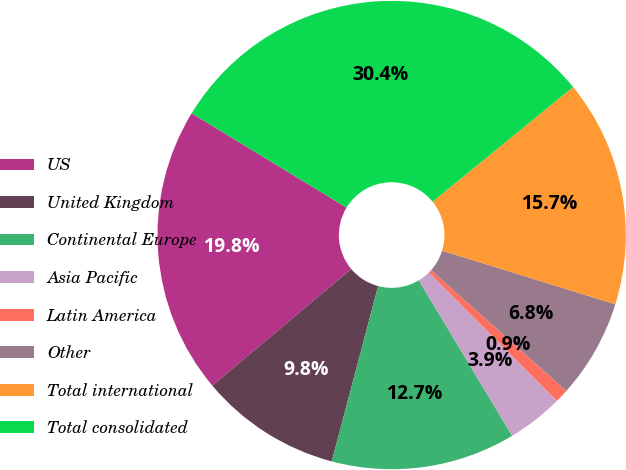Convert chart. <chart><loc_0><loc_0><loc_500><loc_500><pie_chart><fcel>US<fcel>United Kingdom<fcel>Continental Europe<fcel>Asia Pacific<fcel>Latin America<fcel>Other<fcel>Total international<fcel>Total consolidated<nl><fcel>19.82%<fcel>9.77%<fcel>12.72%<fcel>3.87%<fcel>0.93%<fcel>6.82%<fcel>15.67%<fcel>30.41%<nl></chart> 